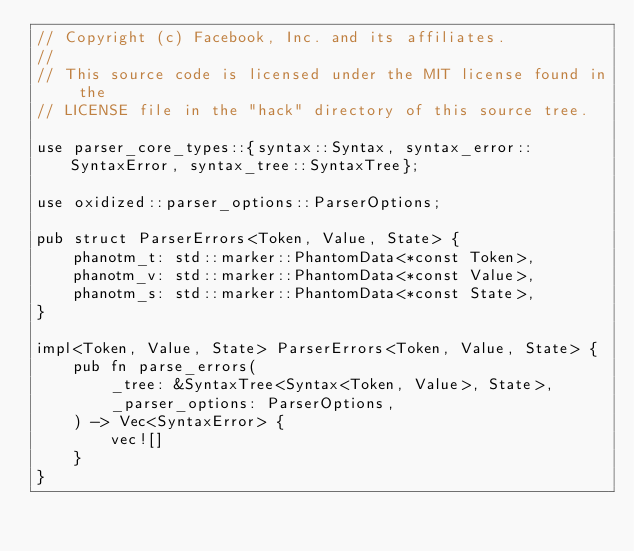<code> <loc_0><loc_0><loc_500><loc_500><_Rust_>// Copyright (c) Facebook, Inc. and its affiliates.
//
// This source code is licensed under the MIT license found in the
// LICENSE file in the "hack" directory of this source tree.

use parser_core_types::{syntax::Syntax, syntax_error::SyntaxError, syntax_tree::SyntaxTree};

use oxidized::parser_options::ParserOptions;

pub struct ParserErrors<Token, Value, State> {
    phanotm_t: std::marker::PhantomData<*const Token>,
    phanotm_v: std::marker::PhantomData<*const Value>,
    phanotm_s: std::marker::PhantomData<*const State>,
}

impl<Token, Value, State> ParserErrors<Token, Value, State> {
    pub fn parse_errors(
        _tree: &SyntaxTree<Syntax<Token, Value>, State>,
        _parser_options: ParserOptions,
    ) -> Vec<SyntaxError> {
        vec![]
    }
}
</code> 